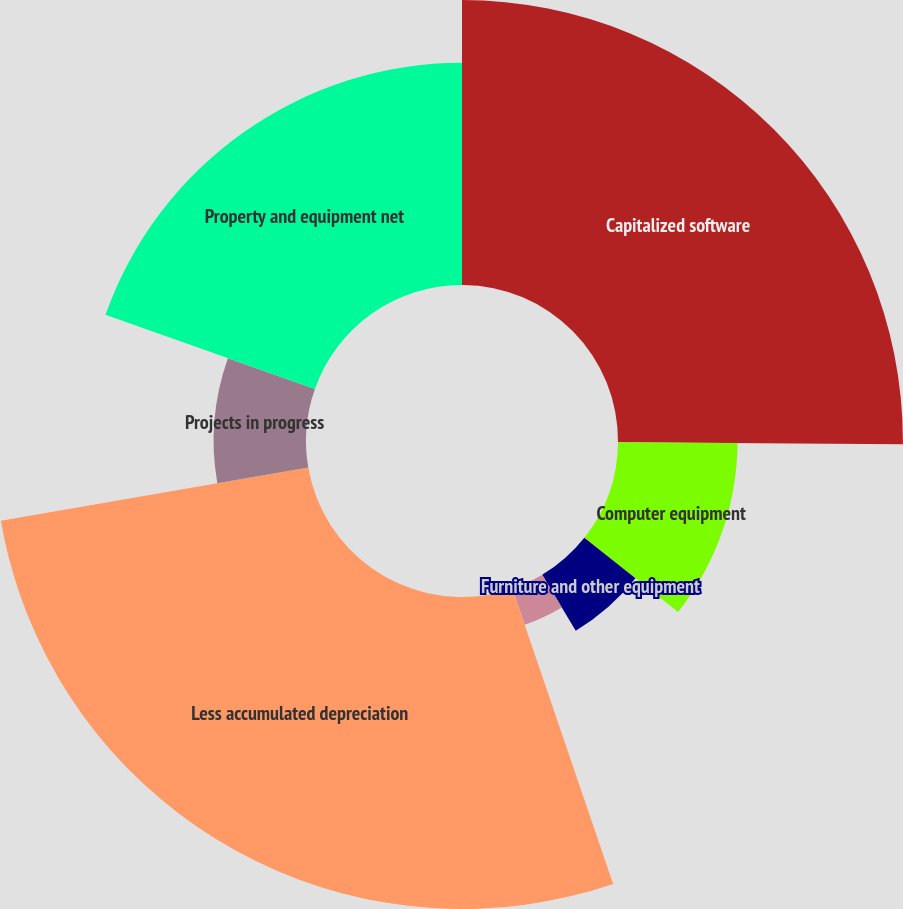Convert chart. <chart><loc_0><loc_0><loc_500><loc_500><pie_chart><fcel>Capitalized software<fcel>Computer equipment<fcel>Furniture and other equipment<fcel>Leasehold improvements<fcel>Less accumulated depreciation<fcel>Projects in progress<fcel>Property and equipment net<nl><fcel>25.12%<fcel>10.54%<fcel>5.75%<fcel>3.36%<fcel>27.51%<fcel>8.14%<fcel>19.59%<nl></chart> 